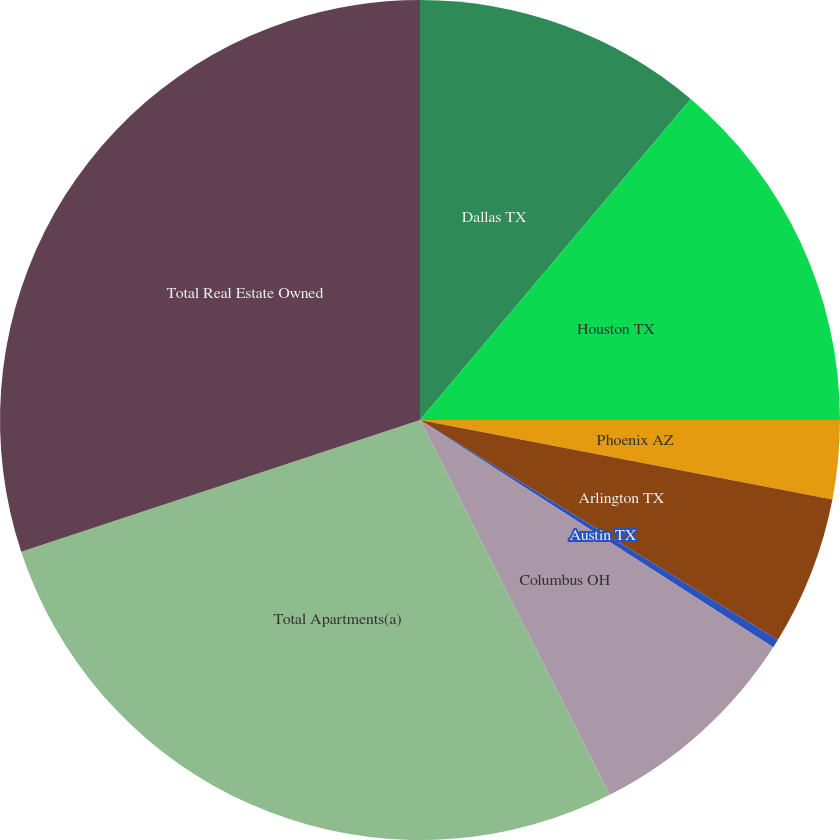Convert chart. <chart><loc_0><loc_0><loc_500><loc_500><pie_chart><fcel>Dallas TX<fcel>Houston TX<fcel>Phoenix AZ<fcel>Arlington TX<fcel>Austin TX<fcel>Columbus OH<fcel>Total Apartments(a)<fcel>Total Real Estate Owned<nl><fcel>11.15%<fcel>13.85%<fcel>3.03%<fcel>5.74%<fcel>0.33%<fcel>8.44%<fcel>27.38%<fcel>30.08%<nl></chart> 